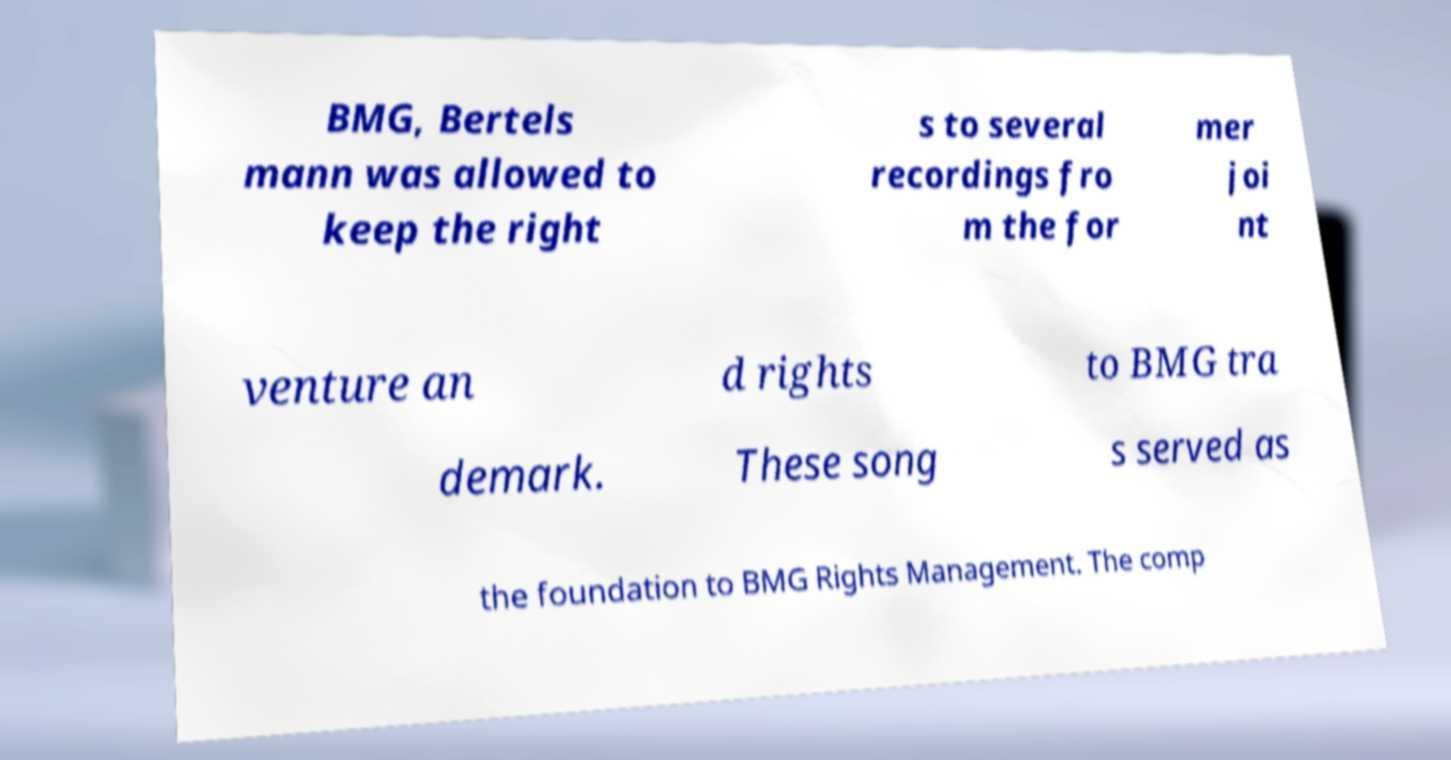Can you accurately transcribe the text from the provided image for me? BMG, Bertels mann was allowed to keep the right s to several recordings fro m the for mer joi nt venture an d rights to BMG tra demark. These song s served as the foundation to BMG Rights Management. The comp 